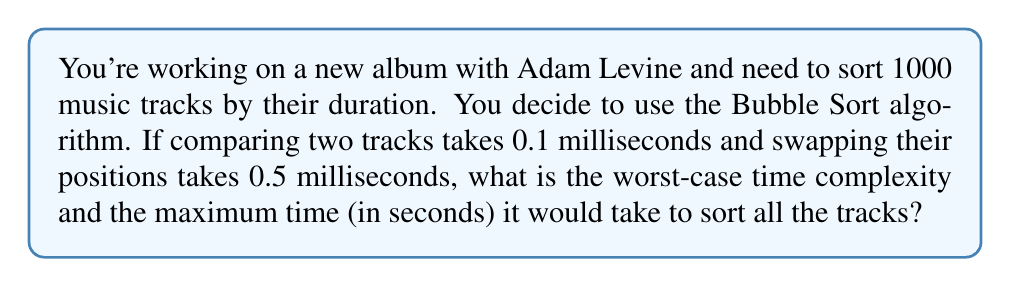Provide a solution to this math problem. To solve this problem, let's break it down into steps:

1. Understand Bubble Sort's worst-case scenario:
   - In the worst case, Bubble Sort makes $n-1$ passes through the list, where $n$ is the number of elements.
   - In each pass, it performs $n-1$ comparisons and up to $n-1$ swaps.

2. Calculate the total number of operations:
   - Number of comparisons: $\sum_{i=1}^{n-1} (n-i) = \frac{n(n-1)}{2}$
   - Number of swaps (worst case): $\sum_{i=1}^{n-1} (n-i) = \frac{n(n-1)}{2}$

3. Determine the time complexity:
   - The time complexity is $O(n^2)$ because of the nested loops in Bubble Sort.

4. Calculate the maximum time:
   - Let $n = 1000$ (number of tracks)
   - Total comparisons: $\frac{1000 \times 999}{2} = 499,500$
   - Total swaps: $499,500$
   - Time for comparisons: $499,500 \times 0.1$ ms $= 49,950$ ms
   - Time for swaps: $499,500 \times 0.5$ ms $= 249,750$ ms
   - Total time: $49,950 + 249,750 = 299,700$ ms $= 299.7$ seconds

Therefore, the worst-case time complexity is $O(n^2)$, and the maximum time to sort 1000 tracks is 299.7 seconds or approximately 5 minutes.
Answer: Time complexity: $O(n^2)$
Maximum time: 299.7 seconds 